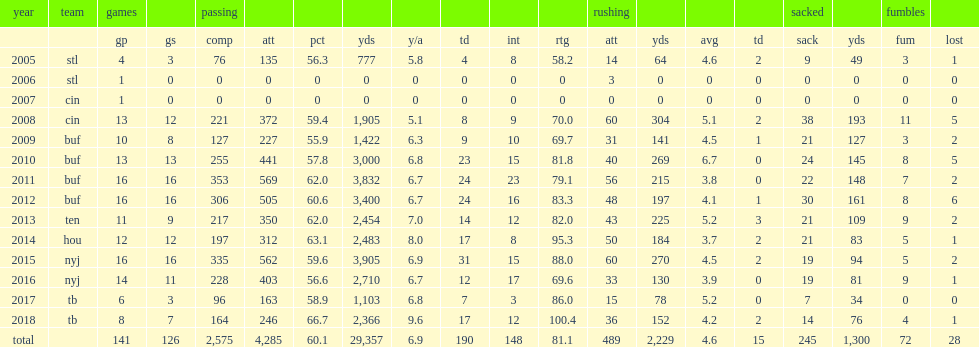How many passing yards did fitzpatrick finish with, in 2018? 2366.0. 